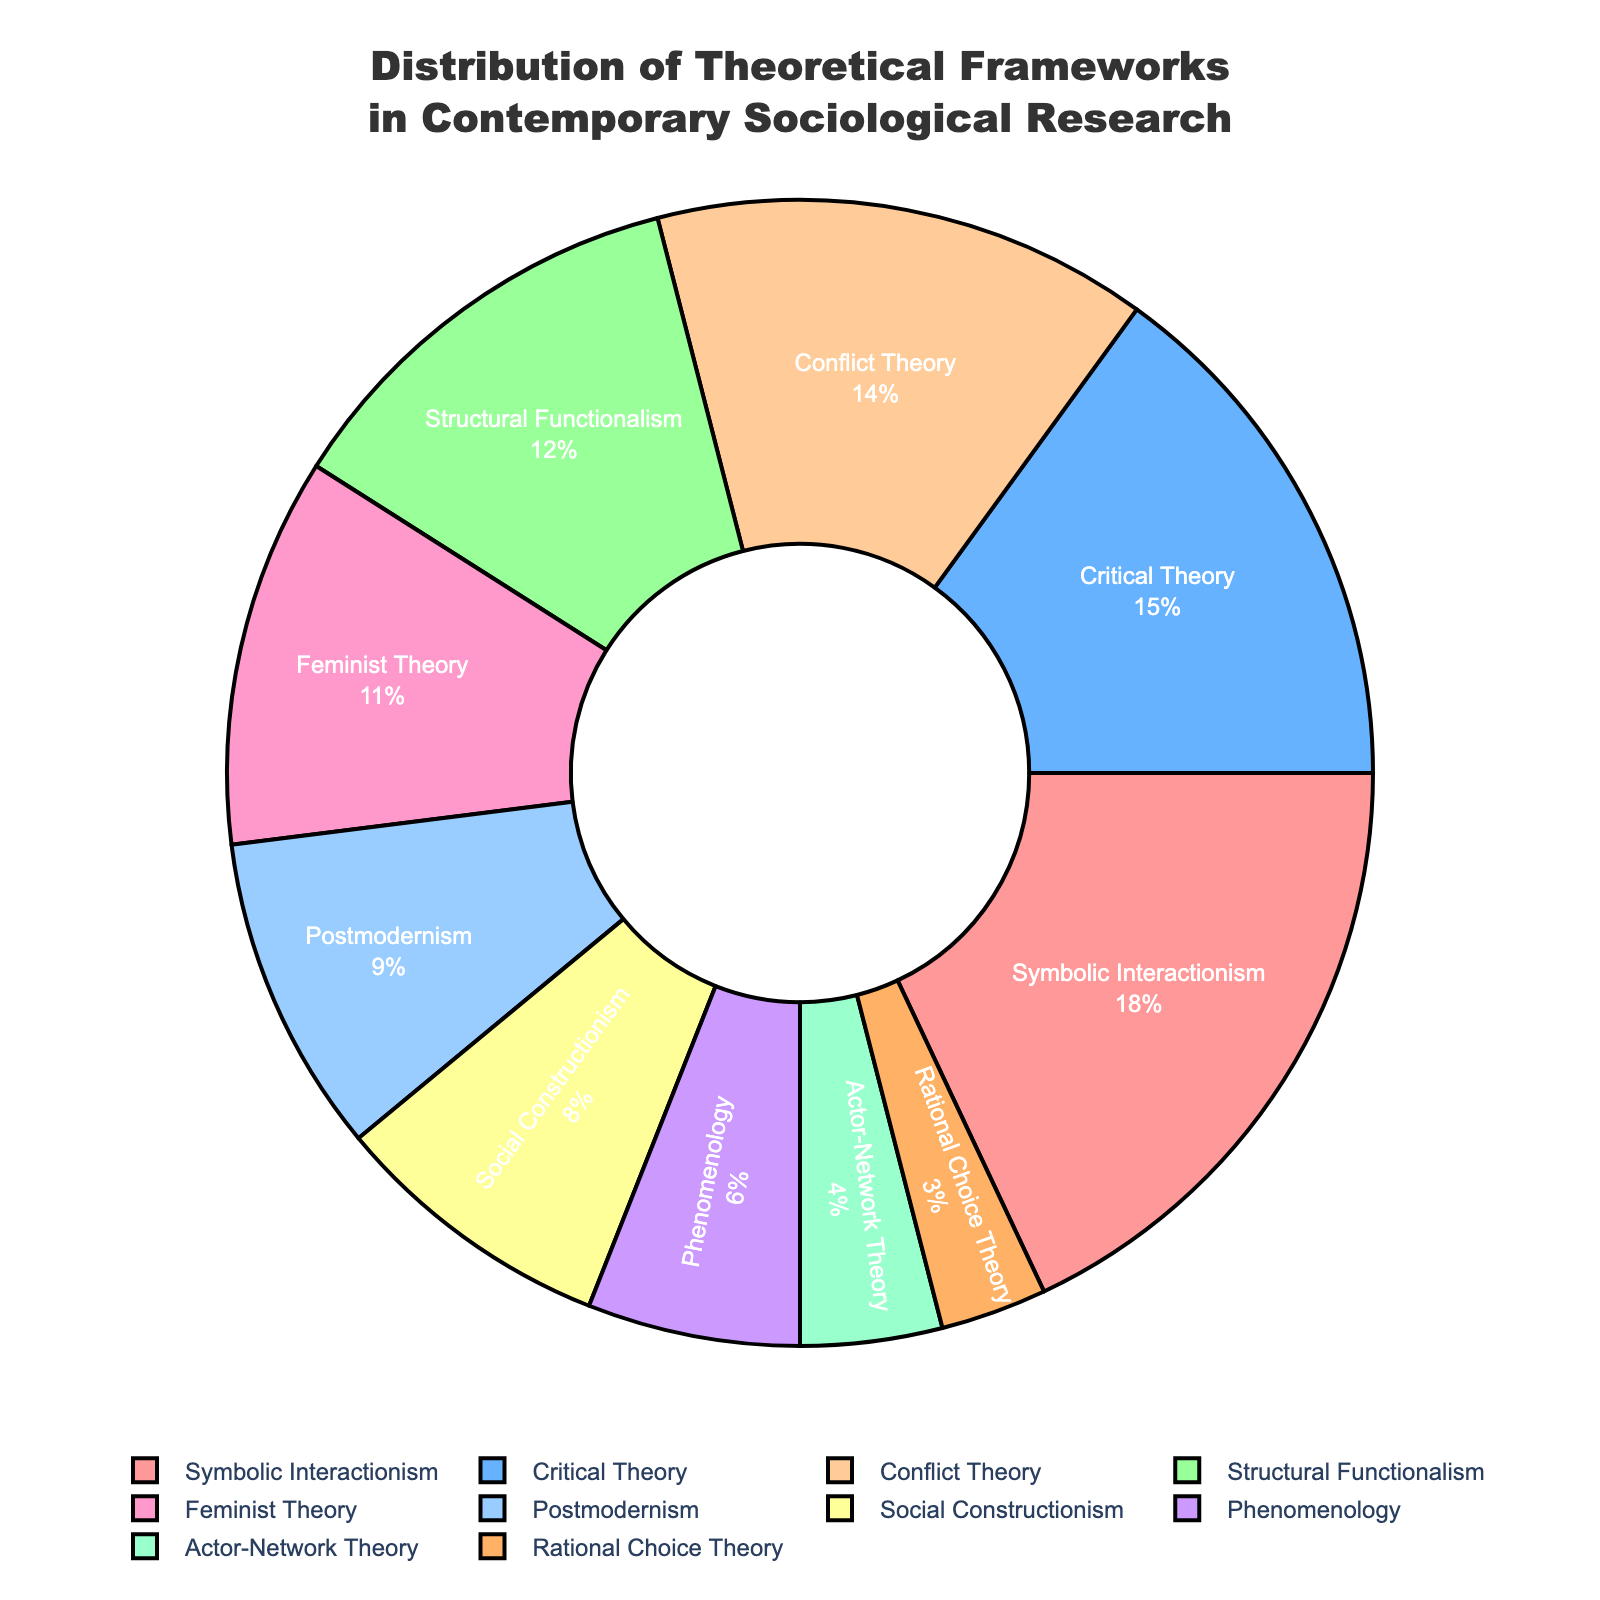What's the most common theoretical framework used in contemporary sociological research? The pie chart shows different theoretical frameworks and their proportions. The largest segment indicates the most common framework, which is Symbolic Interactionism at 18%.
Answer: Symbolic Interactionism Which theoretical framework is applied the least in contemporary sociological research? The pie chart shows several theoretical frameworks with varying percentages. The smallest segment represents the least used framework, which is Rational Choice Theory at 3%.
Answer: Rational Choice Theory What is the combined percentage of Critical Theory and Conflict Theory? The pie chart shows the percentage of each theoretical framework. Add the percentages for Critical Theory (15%) and Conflict Theory (14%): 15% + 14% = 29%.
Answer: 29% How does the proportion of Structural Functionalism compare to Feminist Theory? The pie chart indicates Structural Functionalism at 12% and Feminist Theory at 11%. Therefore, Structural Functionalism has a slightly higher percentage.
Answer: Structural Functionalism is higher Which segment has a higher percentage: Postmodernism or Social Constructionism? The pie chart shows Postmodernism at 9% and Social Constructionism at 8%. Comparing these values, Postmodernism has a higher percentage.
Answer: Postmodernism What percentage of the theoretical frameworks are associated with Symbolic Interactionism, Rational Choice Theory, and Actor-Network Theory combined? The pie chart provides the following percentages: Symbolic Interactionism (18%), Rational Choice Theory (3%), and Actor-Network Theory (4%). Add these percentages together: 18% + 3% + 4% = 25%.
Answer: 25% What is the difference in percentage between the most and least applied theoretical frameworks? The pie chart indicates that Symbolic Interactionism has the highest percentage (18%) and Rational Choice Theory has the lowest (3%). Subtract the smallest percentage from the largest: 18% - 3% = 15%.
Answer: 15% Which color represents the Feminist Theory segment? The pie chart uses different colors to represent each framework. Feminist Theory is represented by the pink segment, positioned at 11%.
Answer: Pink Compare the combined percentages of Symbolic Interactionism and Structural Functionalism to Critical Theory and Conflict Theory. Which is higher? Symbolic Interactionism (18%) and Structural Functionalism (12%) combined is 18% + 12% = 30%. Critical Theory (15%) and Conflict Theory (14%) combined is 15% + 14% = 29%. Therefore, Symbolic Interactionism and Structural Functionalism combined is higher.
Answer: Symbolic Interactionism and Structural Functionalism Which theoretical framework occupies a position closest to 10% on the pie chart? The pie chart shows the percentages, and the framework closest to 10% is Feminist Theory at 11%.
Answer: Feminist Theory 